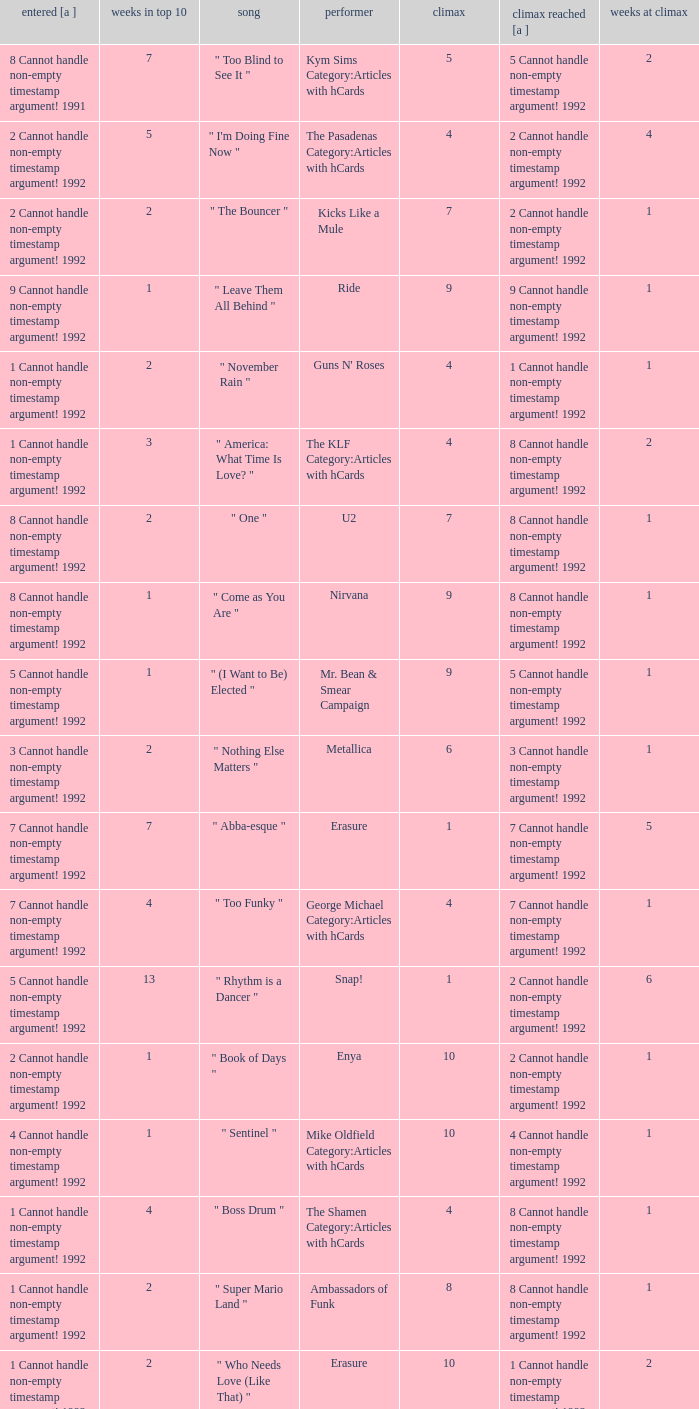What was the peak reached for a single with 4 weeks in the top 10 and entered in 7 cannot handle non-empty timestamp argument! 1992? 7 Cannot handle non-empty timestamp argument! 1992. Give me the full table as a dictionary. {'header': ['entered [a ]', 'weeks in top 10', 'song', 'performer', 'climax', 'climax reached [a ]', 'weeks at climax'], 'rows': [['8 Cannot handle non-empty timestamp argument! 1991', '7', '" Too Blind to See It "', 'Kym Sims Category:Articles with hCards', '5', '5 Cannot handle non-empty timestamp argument! 1992', '2'], ['2 Cannot handle non-empty timestamp argument! 1992', '5', '" I\'m Doing Fine Now "', 'The Pasadenas Category:Articles with hCards', '4', '2 Cannot handle non-empty timestamp argument! 1992', '4'], ['2 Cannot handle non-empty timestamp argument! 1992', '2', '" The Bouncer "', 'Kicks Like a Mule', '7', '2 Cannot handle non-empty timestamp argument! 1992', '1'], ['9 Cannot handle non-empty timestamp argument! 1992', '1', '" Leave Them All Behind "', 'Ride', '9', '9 Cannot handle non-empty timestamp argument! 1992', '1'], ['1 Cannot handle non-empty timestamp argument! 1992', '2', '" November Rain "', "Guns N' Roses", '4', '1 Cannot handle non-empty timestamp argument! 1992', '1'], ['1 Cannot handle non-empty timestamp argument! 1992', '3', '" America: What Time Is Love? "', 'The KLF Category:Articles with hCards', '4', '8 Cannot handle non-empty timestamp argument! 1992', '2'], ['8 Cannot handle non-empty timestamp argument! 1992', '2', '" One "', 'U2', '7', '8 Cannot handle non-empty timestamp argument! 1992', '1'], ['8 Cannot handle non-empty timestamp argument! 1992', '1', '" Come as You Are "', 'Nirvana', '9', '8 Cannot handle non-empty timestamp argument! 1992', '1'], ['5 Cannot handle non-empty timestamp argument! 1992', '1', '" (I Want to Be) Elected "', 'Mr. Bean & Smear Campaign', '9', '5 Cannot handle non-empty timestamp argument! 1992', '1'], ['3 Cannot handle non-empty timestamp argument! 1992', '2', '" Nothing Else Matters "', 'Metallica', '6', '3 Cannot handle non-empty timestamp argument! 1992', '1'], ['7 Cannot handle non-empty timestamp argument! 1992', '7', '" Abba-esque "', 'Erasure', '1', '7 Cannot handle non-empty timestamp argument! 1992', '5'], ['7 Cannot handle non-empty timestamp argument! 1992', '4', '" Too Funky "', 'George Michael Category:Articles with hCards', '4', '7 Cannot handle non-empty timestamp argument! 1992', '1'], ['5 Cannot handle non-empty timestamp argument! 1992', '13', '" Rhythm is a Dancer "', 'Snap!', '1', '2 Cannot handle non-empty timestamp argument! 1992', '6'], ['2 Cannot handle non-empty timestamp argument! 1992', '1', '" Book of Days "', 'Enya', '10', '2 Cannot handle non-empty timestamp argument! 1992', '1'], ['4 Cannot handle non-empty timestamp argument! 1992', '1', '" Sentinel "', 'Mike Oldfield Category:Articles with hCards', '10', '4 Cannot handle non-empty timestamp argument! 1992', '1'], ['1 Cannot handle non-empty timestamp argument! 1992', '4', '" Boss Drum "', 'The Shamen Category:Articles with hCards', '4', '8 Cannot handle non-empty timestamp argument! 1992', '1'], ['1 Cannot handle non-empty timestamp argument! 1992', '2', '" Super Mario Land "', 'Ambassadors of Funk', '8', '8 Cannot handle non-empty timestamp argument! 1992', '1'], ['1 Cannot handle non-empty timestamp argument! 1992', '2', '" Who Needs Love (Like That) "', 'Erasure', '10', '1 Cannot handle non-empty timestamp argument! 1992', '2'], ['8 Cannot handle non-empty timestamp argument! 1992', '2', '" Be My Baby "', 'Vanessa Paradis Category:Articles with hCards', '6', '8 Cannot handle non-empty timestamp argument! 1992', '1'], ['6 Cannot handle non-empty timestamp argument! 1992', '5', '" Slam Jam "', 'WWF Superstars', '4', '6 Cannot handle non-empty timestamp argument! 1992', '2']]} 